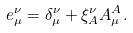<formula> <loc_0><loc_0><loc_500><loc_500>e _ { \mu } ^ { \nu } = \delta _ { \mu } ^ { \nu } + \xi _ { A } ^ { \nu } A _ { \mu } ^ { A } .</formula> 